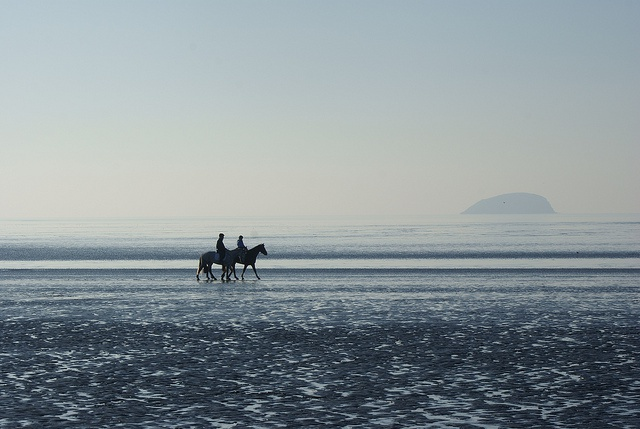Describe the objects in this image and their specific colors. I can see horse in lightblue, black, gray, navy, and darkgray tones, horse in lightblue, black, gray, and blue tones, people in lightblue, black, gray, darkgray, and lightgray tones, and people in lightblue, black, darkgray, gray, and navy tones in this image. 